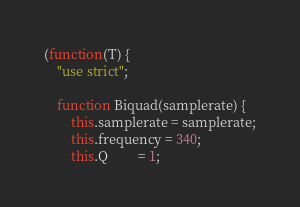<code> <loc_0><loc_0><loc_500><loc_500><_JavaScript_>(function(T) {
    "use strict";

    function Biquad(samplerate) {
        this.samplerate = samplerate;
        this.frequency = 340;
        this.Q         = 1;</code> 